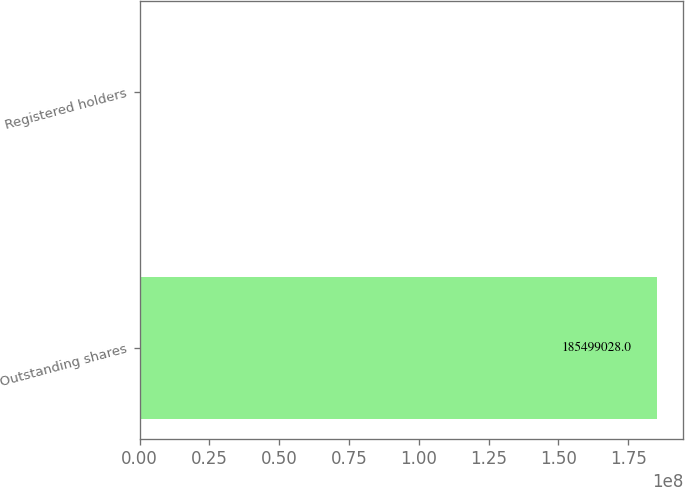Convert chart to OTSL. <chart><loc_0><loc_0><loc_500><loc_500><bar_chart><fcel>Outstanding shares<fcel>Registered holders<nl><fcel>1.85499e+08<fcel>893<nl></chart> 